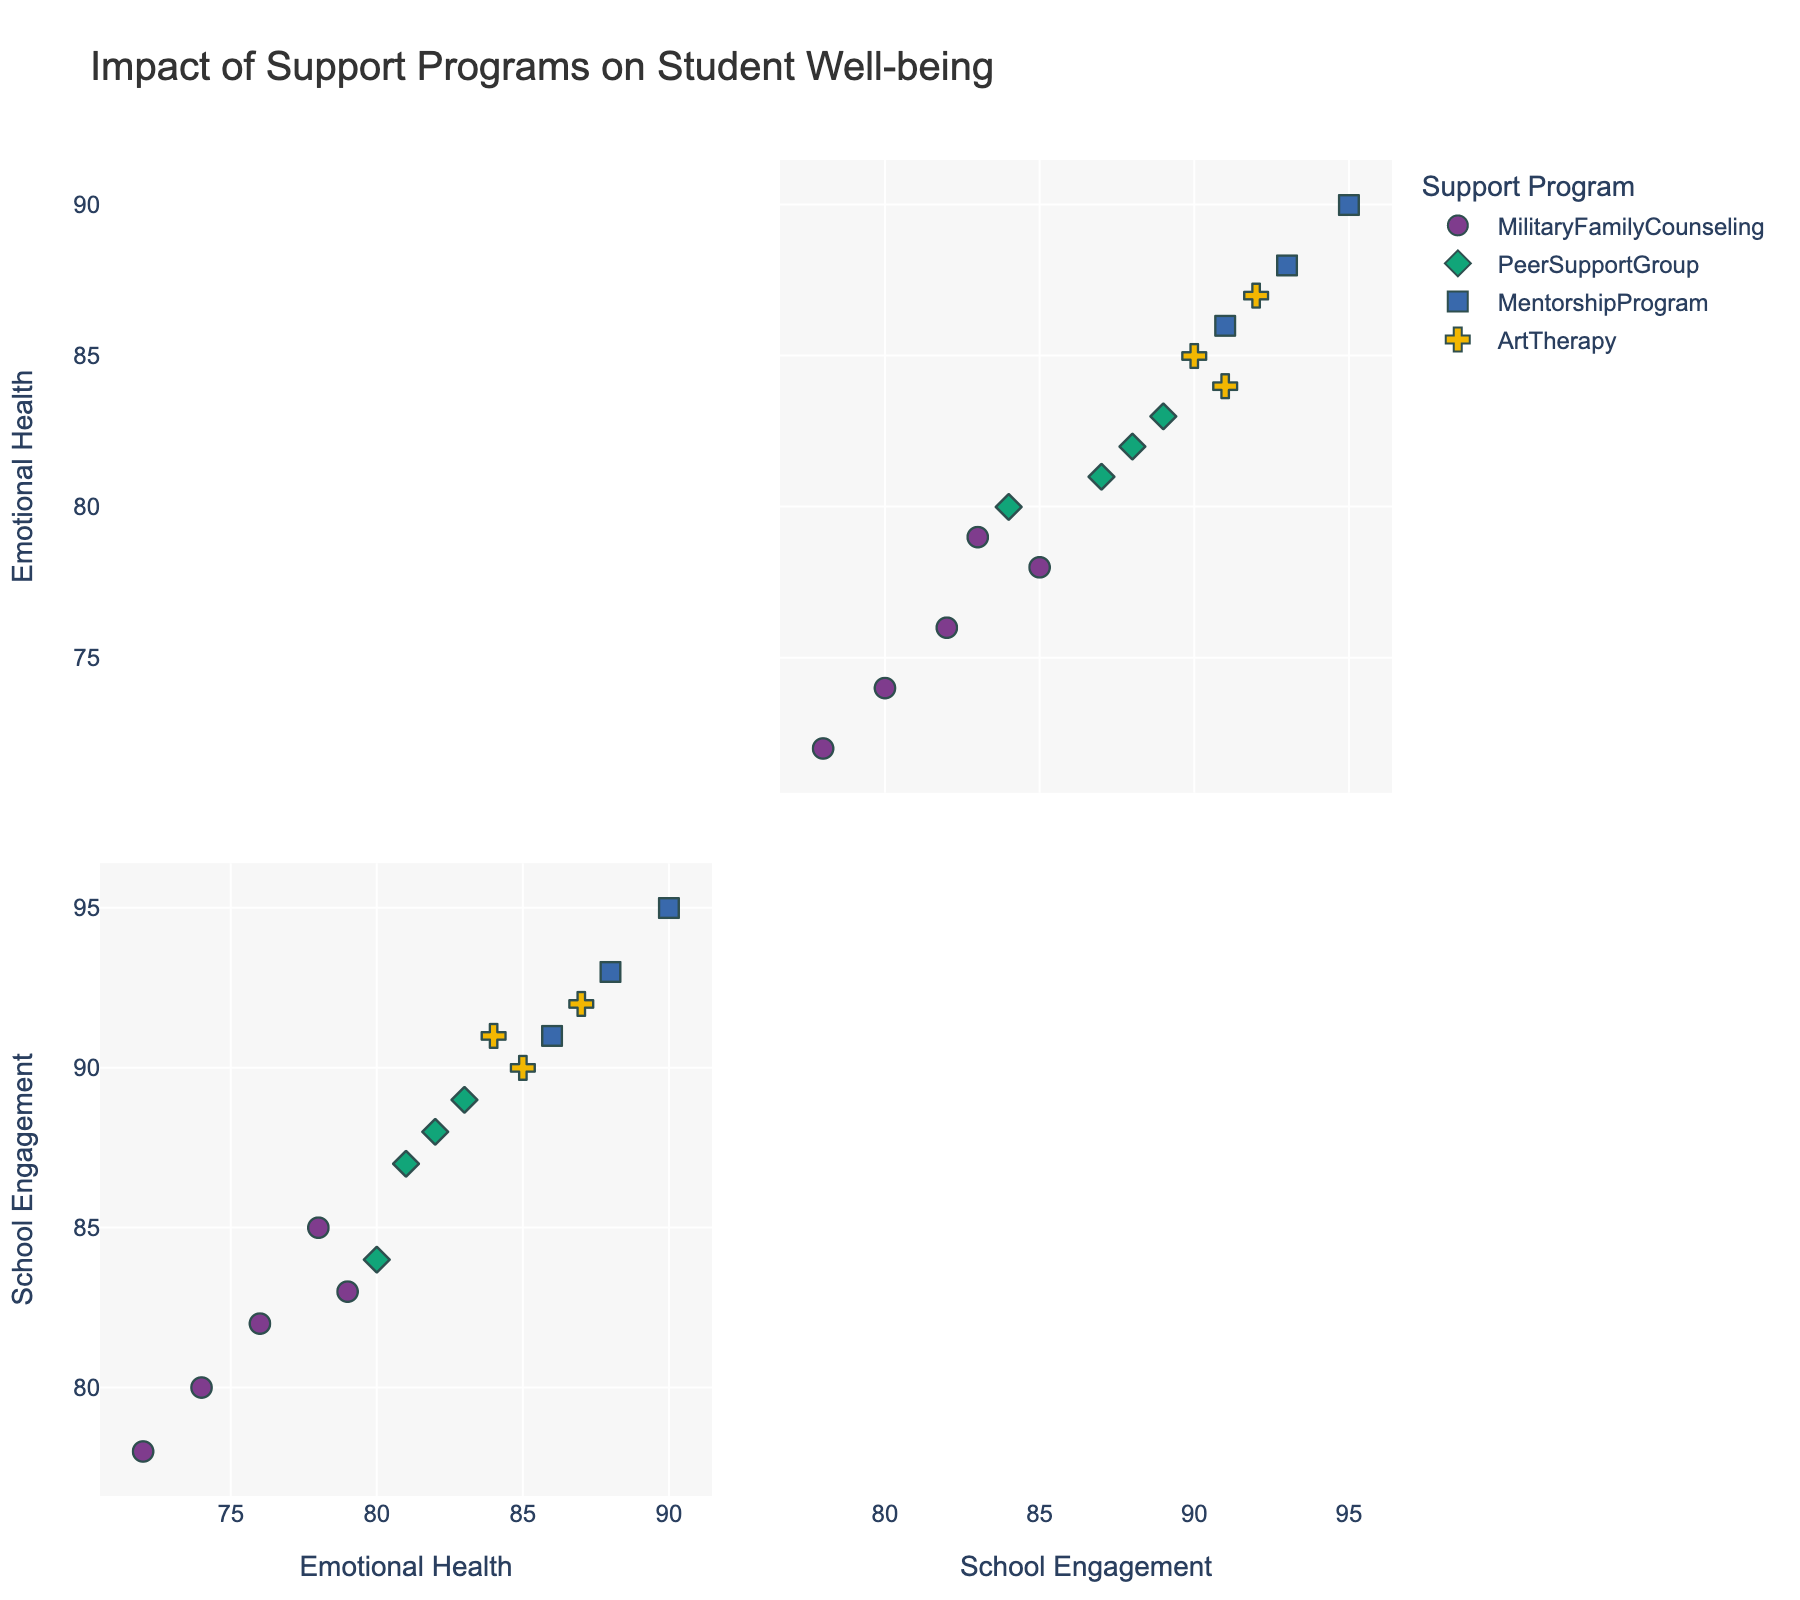What is the title of the plot? The title of the plot can be found at the top of the figure.
Answer: Impact of Support Programs on Student Well-being What are the two main dimensions (axes) used in the scatter plot matrix? The dimensions or axes of the scatter plot matrix are labeled on the sides of the individual scatter plots within the matrix.
Answer: Emotional Health and School Engagement Which support program has the highest Emotional Health Score? By examining the scatter plot matrix, look for the highest points on the vertical axis representing Emotional Health and take note of their corresponding support program colors or symbols.
Answer: Mentorship Program What is the general visual trend between Emotional Health Score and School Engagement Score? Observing the overall pattern of points in the scatter plots, we can determine the relationship between the two dimensions; whether they generally trend upwards, downwards, or show no clear pattern.
Answer: Positive correlation How many support programs are represented in the plot? Each support program is identified by unique colors and symbols within the scatter plot matrix. Count these unique visual identifiers.
Answer: 4 Which support program shows a student with the lowest School Engagement Score? Locate the lowest points of the School Engagement Scores on the horizontal axis and check their respective support programs by their color or symbols.
Answer: Military Family Counseling Between Peer Support Group and Art Therapy, which program generally scores higher on Emotional Health? Compare the distribution of points for Peer Support Group and Art Therapy along the Emotional Health axis to determine which group tends to have higher values.
Answer: Art Therapy Are there any support programs where the students' Emotional Health Score goes below 75? Locate all points on the Emotional Health axis that fall below 75 and identify their associated support programs using color or symbol legend.
Answer: Yes, Military Family Counseling Which support program(s) have students achieving a School Engagement Score above 90? Identify points above 90 on the School Engagement axis and note their support programs using the colors or symbols.
Answer: Mentorship Program, Art Therapy Is there any overlap in Emotional Health Scores between Peer Support Group and Mentorship Program? Examine the range of Emotional Health Scores for both Peer Support Group and Mentorship Program and check if their ranges overlap.
Answer: Yes 